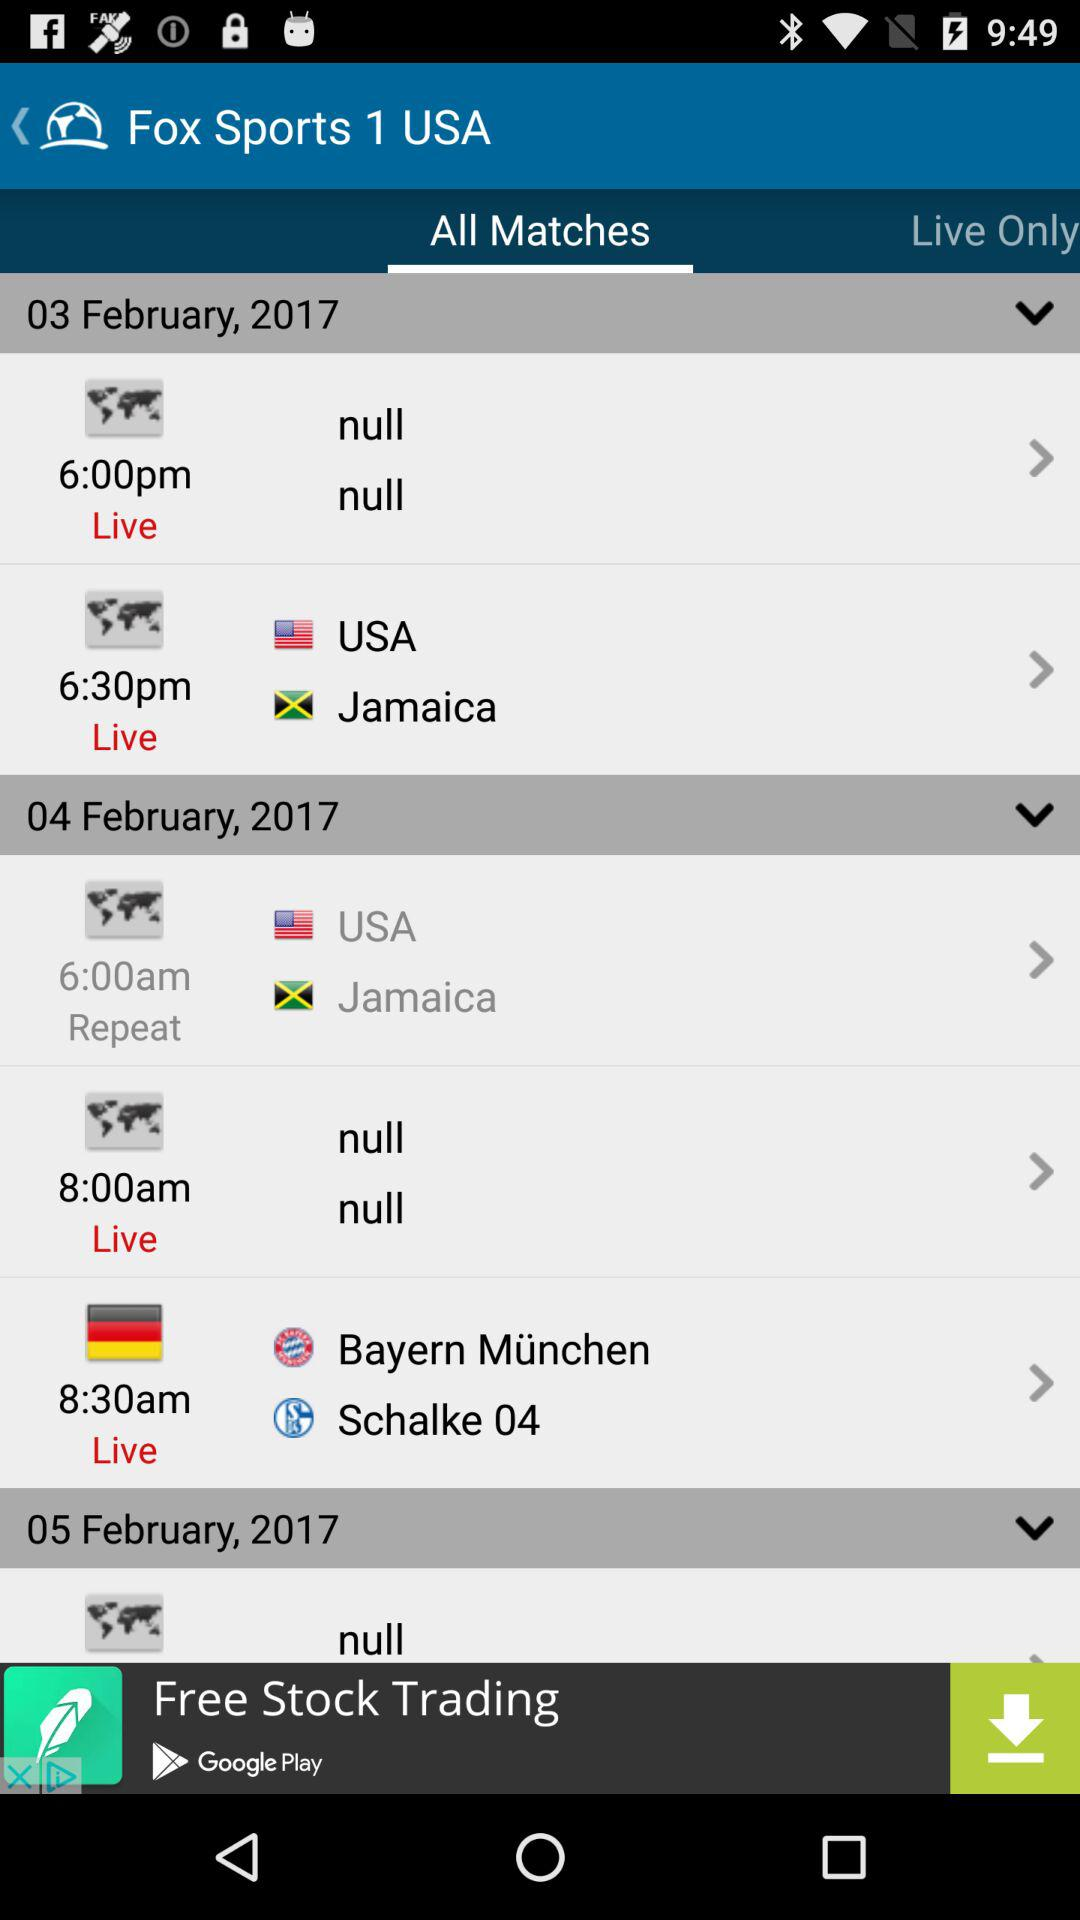When is the live match between "Bayern München" and "Schalke 04" scheduled to take place? The live match between "Bayern München" and "Schalke 04" is scheduled to take place on February 4, 2017 at 8:30 a.m. 